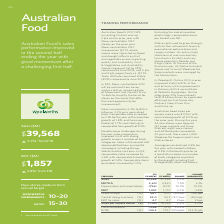According to Woolworths Limited's financial document, How many Woolworths Supermarkets were managed by the Metro team by the end of the financial year? According to the financial document, 16. The relevant text states: "f the financial year, 43 Metro‑branded stores and 16 small Woolworths Supermarkets were managed by the Metro team...." Also, What is the percentage change for Sales during this financial year? According to the financial document, 5.3%. The relevant text states: "Sales 39,568 37,589 5.3% 3.3% EBITDA 2,613 2,430 7.5% 6.1% Depreciation and amortisation (756) (673) 12.3% 12.3% EBIT 1,857 1..." Also, How many Metro-branded stores were managed by the Metro team by the end of the financial year? According to the financial document, 43. The relevant text states: "nd Kings Cross. At the end of the financial year, 43 Metro‑branded stores and 16 small Woolworths Supermarkets were managed by the Metro team...." Also, can you calculate: What is the percentage of Depreciation and amortisation in EBITDA in F19? Based on the calculation: (756/2,613) , the result is 28.93 (percentage). This is based on the information: "13 2,430 7.5% 6.1% Depreciation and amortisation (756) (673) 12.3% 12.3% EBIT 1,857 1,757 5.7% 3.8% Gross margin (%) 28.7 29.0 (24) bps (24) bps Cost of Sales 39,568 37,589 5.3% 3.3% EBITDA 2,613 2,43..." The key data points involved are: 2,613, 756. Also, can you calculate: What is the percentage of EBIT in EBITDA? Based on the calculation: (1,857/2,613) , the result is 71.07 (percentage). This is based on the information: "ion and amortisation (756) (673) 12.3% 12.3% EBIT 1,857 1,757 5.7% 3.8% Gross margin (%) 28.7 29.0 (24) bps (24) bps Cost of doing business (%) 24.0 24.3 ( Sales 39,568 37,589 5.3% 3.3% EBITDA 2,613 2..." The key data points involved are: 1,857, 2,613. Also, can you calculate: What is the nominal difference for Sales between F19 and F18? Based on the calculation: 39,568 - 37,589 , the result is 1979 (in millions). This is based on the information: "Sales 39,568 37,589 5.3% 3.3% EBITDA 2,613 2,430 7.5% 6.1% Depreciation and amortisation (756) (673) 12.3% 12.3% EBIT 1 Sales 39,568 37,589 5.3% 3.3% EBITDA 2,613 2,430 7.5% 6.1% Depreciation and amor..." The key data points involved are: 37,589, 39,568. 